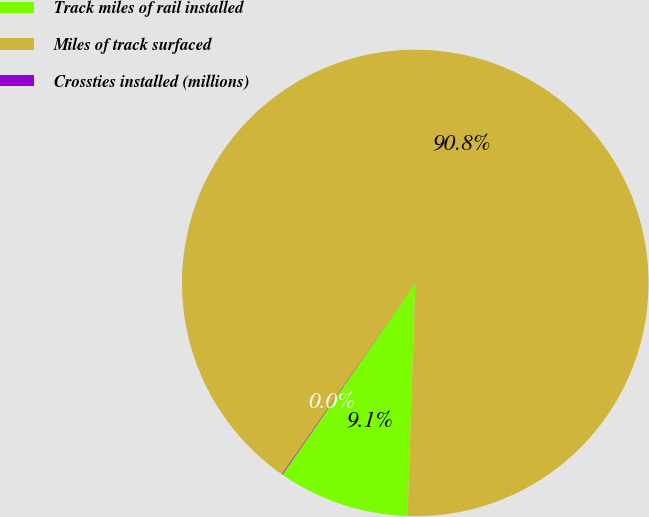<chart> <loc_0><loc_0><loc_500><loc_500><pie_chart><fcel>Track miles of rail installed<fcel>Miles of track surfaced<fcel>Crossties installed (millions)<nl><fcel>9.12%<fcel>90.83%<fcel>0.05%<nl></chart> 